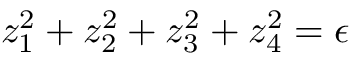Convert formula to latex. <formula><loc_0><loc_0><loc_500><loc_500>z _ { 1 } ^ { 2 } + z _ { 2 } ^ { 2 } + z _ { 3 } ^ { 2 } + z _ { 4 } ^ { 2 } = \epsilon</formula> 